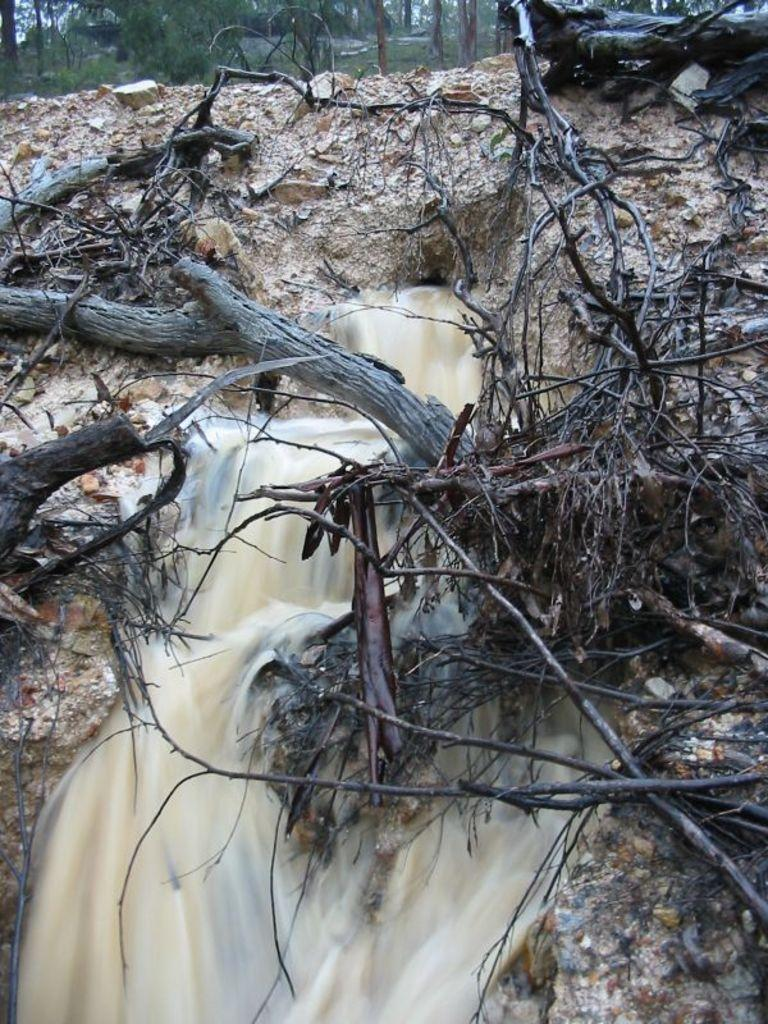What is the main feature in the middle of the image? There is a waterfall in the middle of the image. What else can be seen near the waterfall? There are branches beside the waterfall. What type of vegetation is visible at the top of the image? Trees are visible at the top of the image. How does the monkey feel about the waterfall in the image? There is no monkey present in the image, so it is not possible to determine how a monkey might feel about the waterfall. 